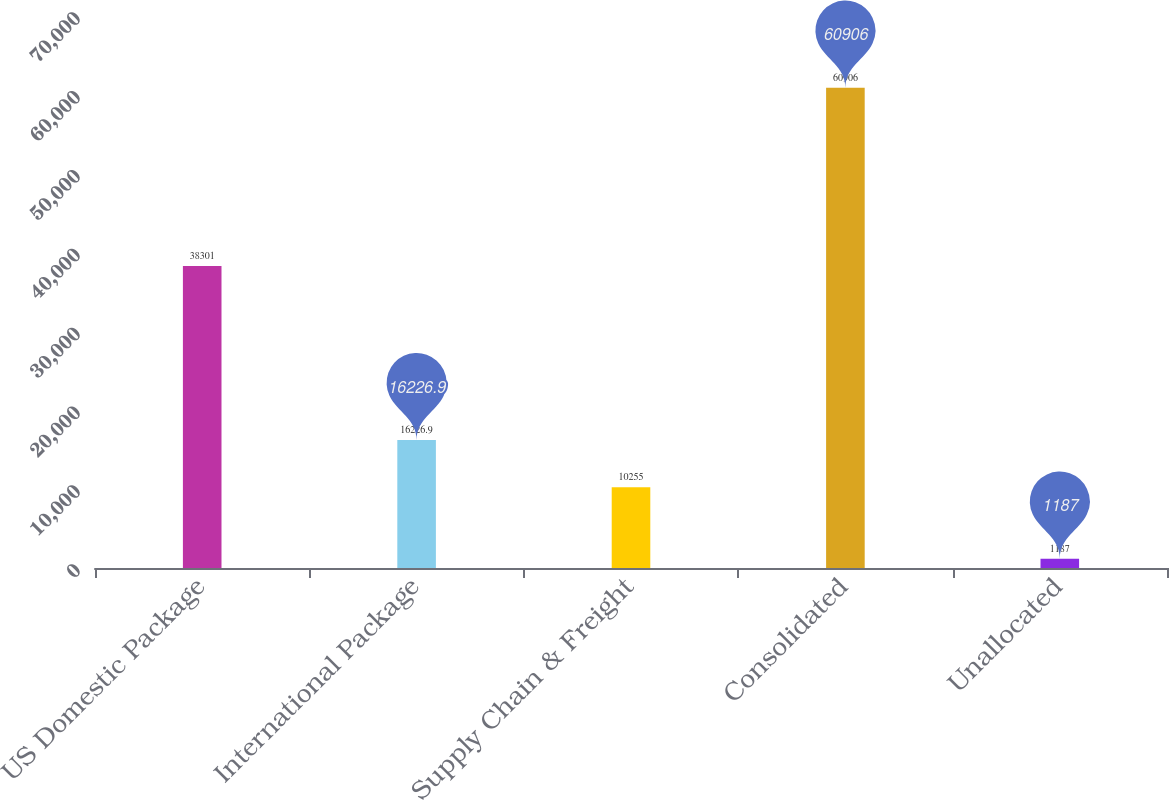Convert chart to OTSL. <chart><loc_0><loc_0><loc_500><loc_500><bar_chart><fcel>US Domestic Package<fcel>International Package<fcel>Supply Chain & Freight<fcel>Consolidated<fcel>Unallocated<nl><fcel>38301<fcel>16226.9<fcel>10255<fcel>60906<fcel>1187<nl></chart> 